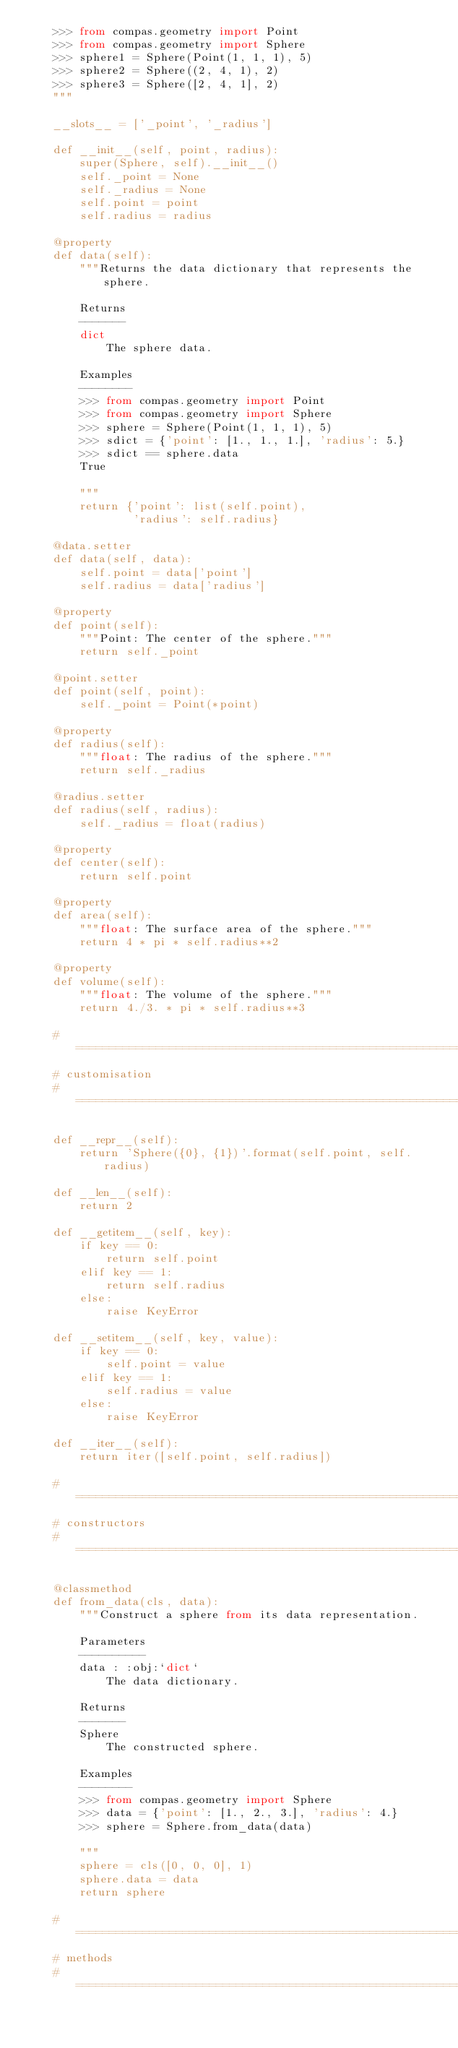<code> <loc_0><loc_0><loc_500><loc_500><_Python_>    >>> from compas.geometry import Point
    >>> from compas.geometry import Sphere
    >>> sphere1 = Sphere(Point(1, 1, 1), 5)
    >>> sphere2 = Sphere((2, 4, 1), 2)
    >>> sphere3 = Sphere([2, 4, 1], 2)
    """

    __slots__ = ['_point', '_radius']

    def __init__(self, point, radius):
        super(Sphere, self).__init__()
        self._point = None
        self._radius = None
        self.point = point
        self.radius = radius

    @property
    def data(self):
        """Returns the data dictionary that represents the sphere.

        Returns
        -------
        dict
            The sphere data.

        Examples
        --------
        >>> from compas.geometry import Point
        >>> from compas.geometry import Sphere
        >>> sphere = Sphere(Point(1, 1, 1), 5)
        >>> sdict = {'point': [1., 1., 1.], 'radius': 5.}
        >>> sdict == sphere.data
        True

        """
        return {'point': list(self.point),
                'radius': self.radius}

    @data.setter
    def data(self, data):
        self.point = data['point']
        self.radius = data['radius']

    @property
    def point(self):
        """Point: The center of the sphere."""
        return self._point

    @point.setter
    def point(self, point):
        self._point = Point(*point)

    @property
    def radius(self):
        """float: The radius of the sphere."""
        return self._radius

    @radius.setter
    def radius(self, radius):
        self._radius = float(radius)

    @property
    def center(self):
        return self.point

    @property
    def area(self):
        """float: The surface area of the sphere."""
        return 4 * pi * self.radius**2

    @property
    def volume(self):
        """float: The volume of the sphere."""
        return 4./3. * pi * self.radius**3

    # ==========================================================================
    # customisation
    # ==========================================================================

    def __repr__(self):
        return 'Sphere({0}, {1})'.format(self.point, self.radius)

    def __len__(self):
        return 2

    def __getitem__(self, key):
        if key == 0:
            return self.point
        elif key == 1:
            return self.radius
        else:
            raise KeyError

    def __setitem__(self, key, value):
        if key == 0:
            self.point = value
        elif key == 1:
            self.radius = value
        else:
            raise KeyError

    def __iter__(self):
        return iter([self.point, self.radius])

    # ==========================================================================
    # constructors
    # ==========================================================================

    @classmethod
    def from_data(cls, data):
        """Construct a sphere from its data representation.

        Parameters
        ----------
        data : :obj:`dict`
            The data dictionary.

        Returns
        -------
        Sphere
            The constructed sphere.

        Examples
        --------
        >>> from compas.geometry import Sphere
        >>> data = {'point': [1., 2., 3.], 'radius': 4.}
        >>> sphere = Sphere.from_data(data)

        """
        sphere = cls([0, 0, 0], 1)
        sphere.data = data
        return sphere

    # ==========================================================================
    # methods
    # ==========================================================================
</code> 